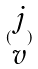<formula> <loc_0><loc_0><loc_500><loc_500>( \begin{matrix} j \\ v \end{matrix} )</formula> 